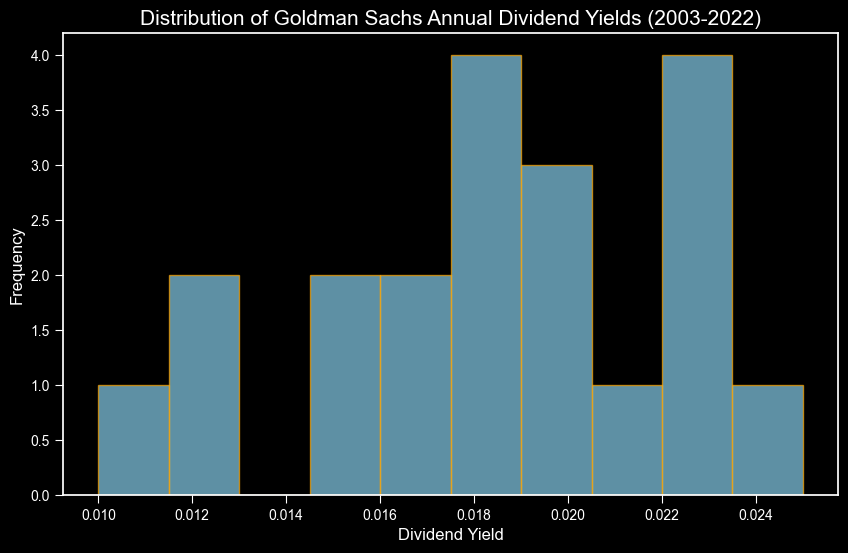What is the most common dividend yield range for Goldman Sachs from 2003 to 2022? Looking at the histogram, identify the bin with the highest frequency. The range corresponding to this bin is the most common dividend yield range.
Answer: 0.018 to 0.02 How many years had a dividend yield between 0.02 and 0.022? Count the bar heights in the bins corresponding to the range of 0.02 to 0.022. There are two bins in this range, each representing different sub-ranges. Sum the frequencies of these bins.
Answer: 4 Which range has the lowest frequency of dividend yields? Identify the bin with the lowest height. The range corresponding to this bin has the lowest frequency.
Answer: 0.01 to 0.012 What is the total number of years represented in the histogram? Sum the frequencies of all the bins in the histogram to get the total number of years.
Answer: 20 Is the dividend yield ever higher than 0.025? Check the bins to see if there is any bin range starting above 0.025.
Answer: No How does the frequency of years with a dividend yield of 0.023 compare to the frequency of years with a dividend yield of 0.012? Locate the bin for each specified dividend yield. Compare their heights.
Answer: 0.023 > 0.012 Which dividend yield range is represented by the light blue bars with orange edges? Look at the colors used in the histogram: all bins are light blue with orange edges. Hence, all dividend yield ranges are represented by these colors.
Answer: All ranges What is the approximate average dividend yield over the past 20 years according to the histogram? To estimate the average visually, identify the midpoint of the histogram's distribution peak. The average dividend yield is roughly around this peak.
Answer: Approximately 0.019 Between which years did Goldman Sachs most frequently have a dividend yield in the 0.018-0.02 range? Verify from the data to identify the years corresponding to the 0.018 to 0.02 bin range. The heights can give clues, but the actual years have to be verified.
Answer: 2005-2006, 2013-2018 Does the histogram suggest that Goldman Sachs has consistently increasing dividends over the years? Analyze the spread and height of the histogram. Consistently increasing dividends should shift the distribution towards higher yields over time. The heights and spread indicate variability without a clear consistent increase.
Answer: No 